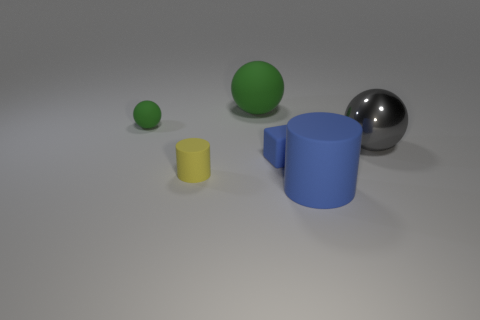What is the shape of the large rubber thing in front of the small green rubber object? The large rubber object in front of the small green one is a cylinder with a blue color. It stands upright and has a circular top that's visible from this angle. 